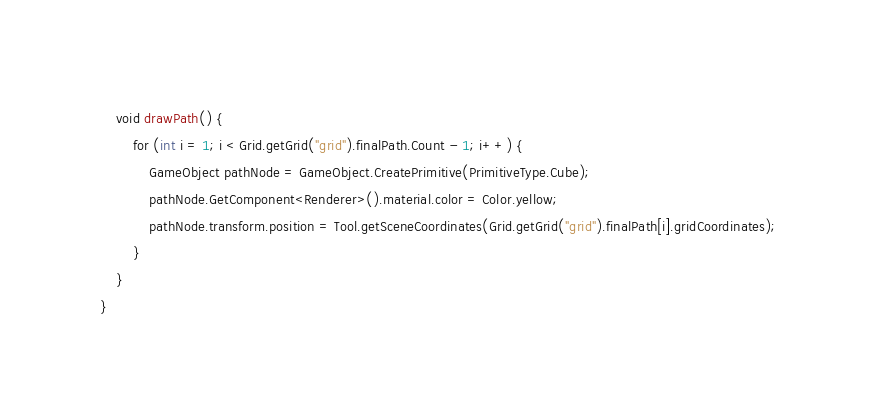Convert code to text. <code><loc_0><loc_0><loc_500><loc_500><_C#_>    void drawPath() {
        for (int i = 1; i < Grid.getGrid("grid").finalPath.Count - 1; i++) {
            GameObject pathNode = GameObject.CreatePrimitive(PrimitiveType.Cube);
            pathNode.GetComponent<Renderer>().material.color = Color.yellow;
            pathNode.transform.position = Tool.getSceneCoordinates(Grid.getGrid("grid").finalPath[i].gridCoordinates);
        }
    }
}
</code> 